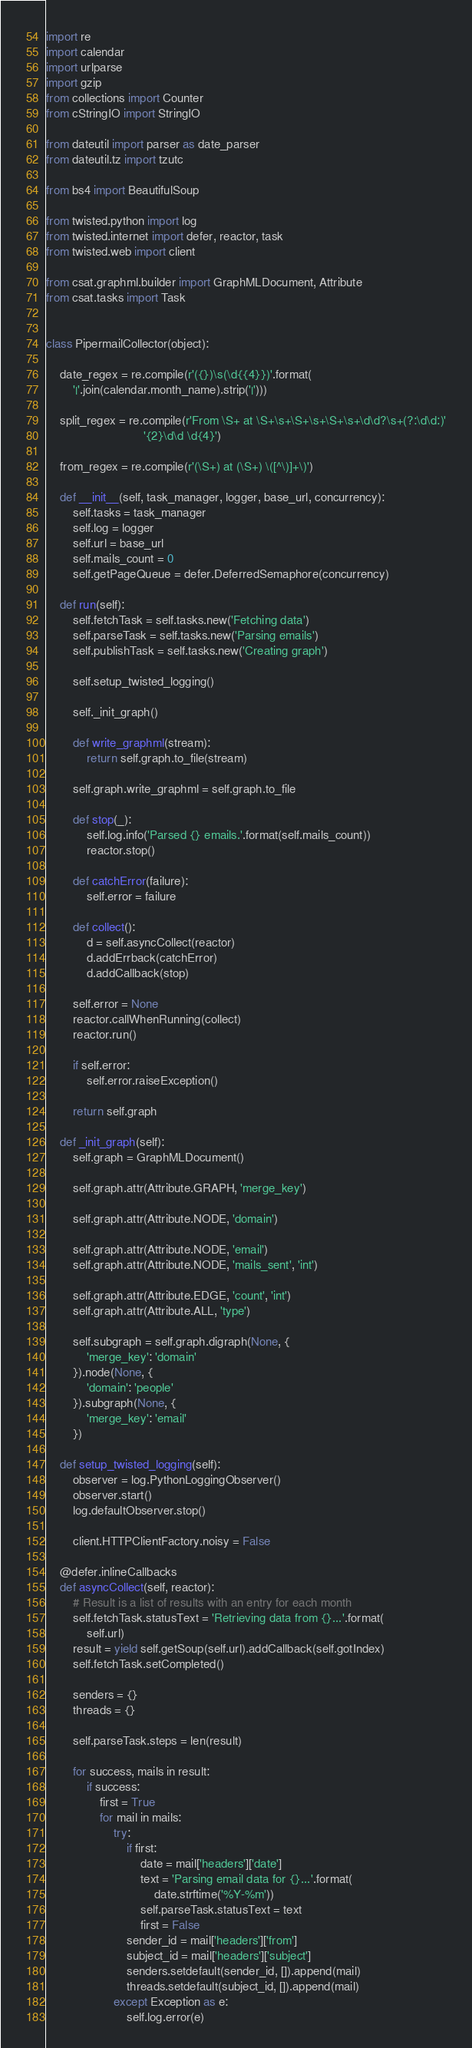<code> <loc_0><loc_0><loc_500><loc_500><_Python_>import re
import calendar
import urlparse
import gzip
from collections import Counter
from cStringIO import StringIO

from dateutil import parser as date_parser
from dateutil.tz import tzutc

from bs4 import BeautifulSoup

from twisted.python import log
from twisted.internet import defer, reactor, task
from twisted.web import client

from csat.graphml.builder import GraphMLDocument, Attribute
from csat.tasks import Task


class PipermailCollector(object):

    date_regex = re.compile(r'({})\s(\d{{4}})'.format(
        '|'.join(calendar.month_name).strip('|')))

    split_regex = re.compile(r'From \S+ at \S+\s+\S+\s+\S+\s+\d\d?\s+(?:\d\d:)'
                             '{2}\d\d \d{4}')

    from_regex = re.compile(r'(\S+) at (\S+) \([^\)]+\)')

    def __init__(self, task_manager, logger, base_url, concurrency):
        self.tasks = task_manager
        self.log = logger
        self.url = base_url
        self.mails_count = 0
        self.getPageQueue = defer.DeferredSemaphore(concurrency)

    def run(self):
        self.fetchTask = self.tasks.new('Fetching data')
        self.parseTask = self.tasks.new('Parsing emails')
        self.publishTask = self.tasks.new('Creating graph')

        self.setup_twisted_logging()

        self._init_graph()

        def write_graphml(stream):
            return self.graph.to_file(stream)

        self.graph.write_graphml = self.graph.to_file

        def stop(_):
            self.log.info('Parsed {} emails.'.format(self.mails_count))
            reactor.stop()

        def catchError(failure):
            self.error = failure

        def collect():
            d = self.asyncCollect(reactor)
            d.addErrback(catchError)
            d.addCallback(stop)

        self.error = None
        reactor.callWhenRunning(collect)
        reactor.run()

        if self.error:
            self.error.raiseException()

        return self.graph

    def _init_graph(self):
        self.graph = GraphMLDocument()

        self.graph.attr(Attribute.GRAPH, 'merge_key')

        self.graph.attr(Attribute.NODE, 'domain')

        self.graph.attr(Attribute.NODE, 'email')
        self.graph.attr(Attribute.NODE, 'mails_sent', 'int')

        self.graph.attr(Attribute.EDGE, 'count', 'int')
        self.graph.attr(Attribute.ALL, 'type')

        self.subgraph = self.graph.digraph(None, {
            'merge_key': 'domain'
        }).node(None, {
            'domain': 'people'
        }).subgraph(None, {
            'merge_key': 'email'
        })

    def setup_twisted_logging(self):
        observer = log.PythonLoggingObserver()
        observer.start()
        log.defaultObserver.stop()

        client.HTTPClientFactory.noisy = False

    @defer.inlineCallbacks
    def asyncCollect(self, reactor):
        # Result is a list of results with an entry for each month
        self.fetchTask.statusText = 'Retrieving data from {}...'.format(
            self.url)
        result = yield self.getSoup(self.url).addCallback(self.gotIndex)
        self.fetchTask.setCompleted()

        senders = {}
        threads = {}

        self.parseTask.steps = len(result)

        for success, mails in result:
            if success:
                first = True
                for mail in mails:
                    try:
                        if first:
                            date = mail['headers']['date']
                            text = 'Parsing email data for {}...'.format(
                                date.strftime('%Y-%m'))
                            self.parseTask.statusText = text
                            first = False
                        sender_id = mail['headers']['from']
                        subject_id = mail['headers']['subject']
                        senders.setdefault(sender_id, []).append(mail)
                        threads.setdefault(subject_id, []).append(mail)
                    except Exception as e:
                        self.log.error(e)</code> 